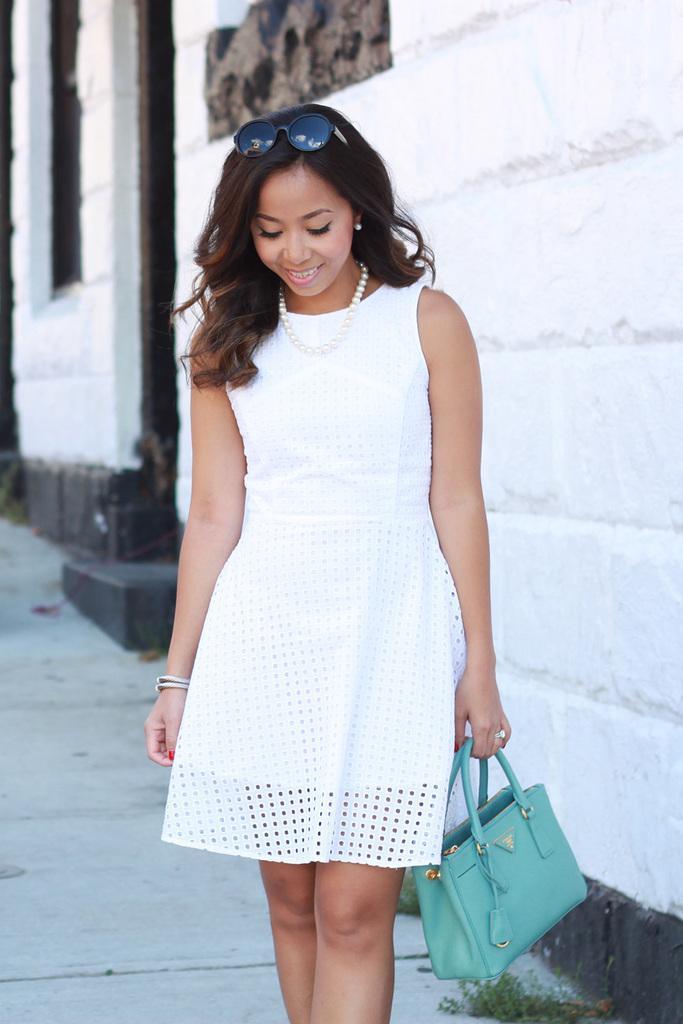Could you give a brief overview of what you see in this image? In this picture we can see a woman standing on the ground, and holding a handbag in her hand, she is wearing the glasses on head, and at back there is wall. 